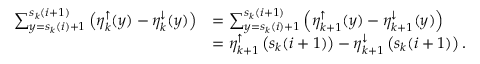Convert formula to latex. <formula><loc_0><loc_0><loc_500><loc_500>\begin{array} { r l } { \sum _ { y = s _ { k } ( i ) + 1 } ^ { s _ { k } ( i + 1 ) } \left ( \eta _ { k } ^ { \uparrow } ( y ) - \eta _ { k } ^ { \downarrow } ( y ) \right ) } & { = \sum _ { y = s _ { k } ( i ) + 1 } ^ { s _ { k } ( i + 1 ) } \left ( \eta _ { k + 1 } ^ { \uparrow } ( y ) - \eta _ { k + 1 } ^ { \downarrow } ( y ) \right ) } \\ & { = \eta _ { k + 1 } ^ { \uparrow } \left ( s _ { k } ( i + 1 ) \right ) - \eta _ { k + 1 } ^ { \downarrow } \left ( s _ { k } ( i + 1 ) \right ) . } \end{array}</formula> 